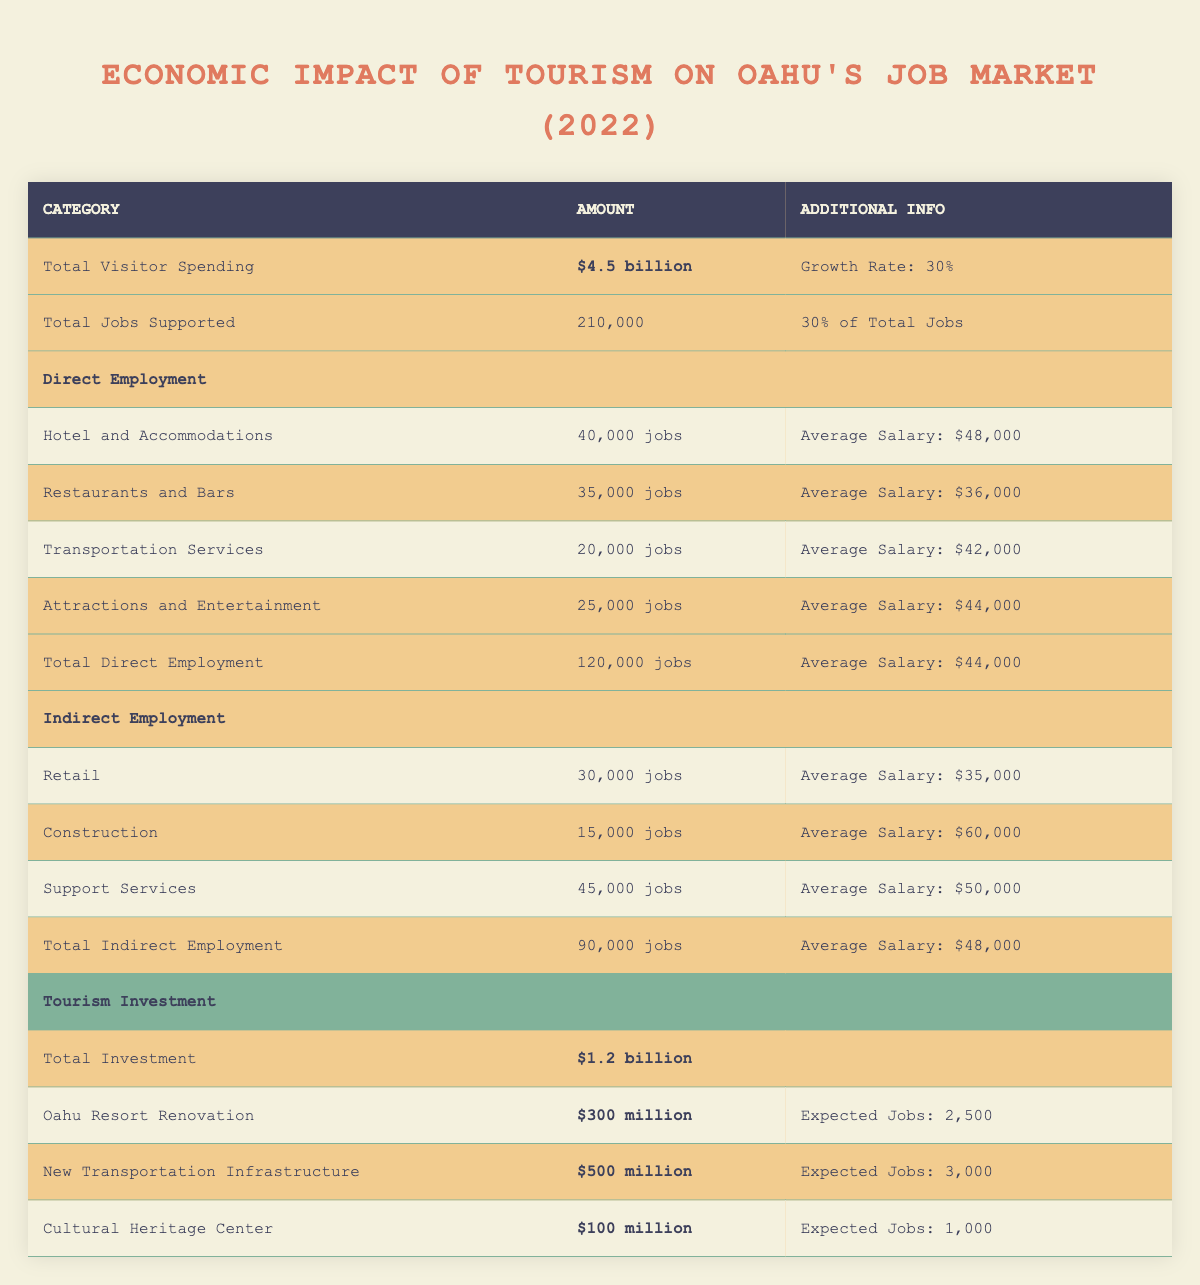What was the total visitor spending in 2022? The table states that the total visitor spending in 2022 was $4.5 billion.
Answer: $4.5 billion What percentage of total jobs does tourism support in Oahu? According to the table, tourism supports 30% of total jobs in Oahu.
Answer: 30% How many jobs does the hotel and accommodations sector provide? The table shows that the hotel and accommodations sector provides 40,000 jobs.
Answer: 40,000 jobs What is the average salary for jobs in the restaurant and bars sector? The table indicates that the average salary for jobs in the restaurant and bars sector is $36,000.
Answer: $36,000 What is the total estimated investment in tourism projects? The table lists the total estimated investment in tourism projects as $1.2 billion.
Answer: $1.2 billion How many jobs are expected to be created from the new transportation infrastructure project? From the table, the new transportation infrastructure project is expected to create 3,000 jobs.
Answer: 3,000 jobs What is the total number of jobs supported by indirect employment? The table states that indirect employment supports a total of 90,000 jobs.
Answer: 90,000 jobs What is the average salary for all jobs supported by direct employment? The table provides that the average salary for jobs in direct employment is $44,000, calculated from the individual sectors mentioned.
Answer: $44,000 Is the average salary for construction jobs higher or lower than the overall average for indirect employment? The average salary for construction jobs is $60,000, while the average for total indirect employment is $48,000, therefore, it is higher.
Answer: Yes, it is higher How many total jobs are supported directly and indirectly by tourism in Oahu? The table states that direct employment supports 120,000 jobs and indirect employment supports 90,000 jobs. Summing these gives 210,000 jobs in total supported by tourism.
Answer: 210,000 jobs 